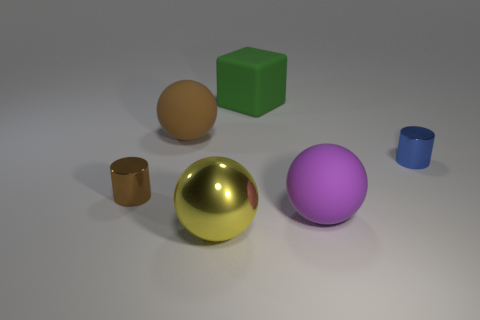Subtract all large metal spheres. How many spheres are left? 2 Subtract 1 spheres. How many spheres are left? 2 Add 1 yellow metallic objects. How many objects exist? 7 Subtract all blocks. How many objects are left? 5 Subtract all blue spheres. Subtract all green cubes. How many spheres are left? 3 Add 2 matte blocks. How many matte blocks are left? 3 Add 6 large purple rubber things. How many large purple rubber things exist? 7 Subtract 0 blue balls. How many objects are left? 6 Subtract all small cylinders. Subtract all brown cylinders. How many objects are left? 3 